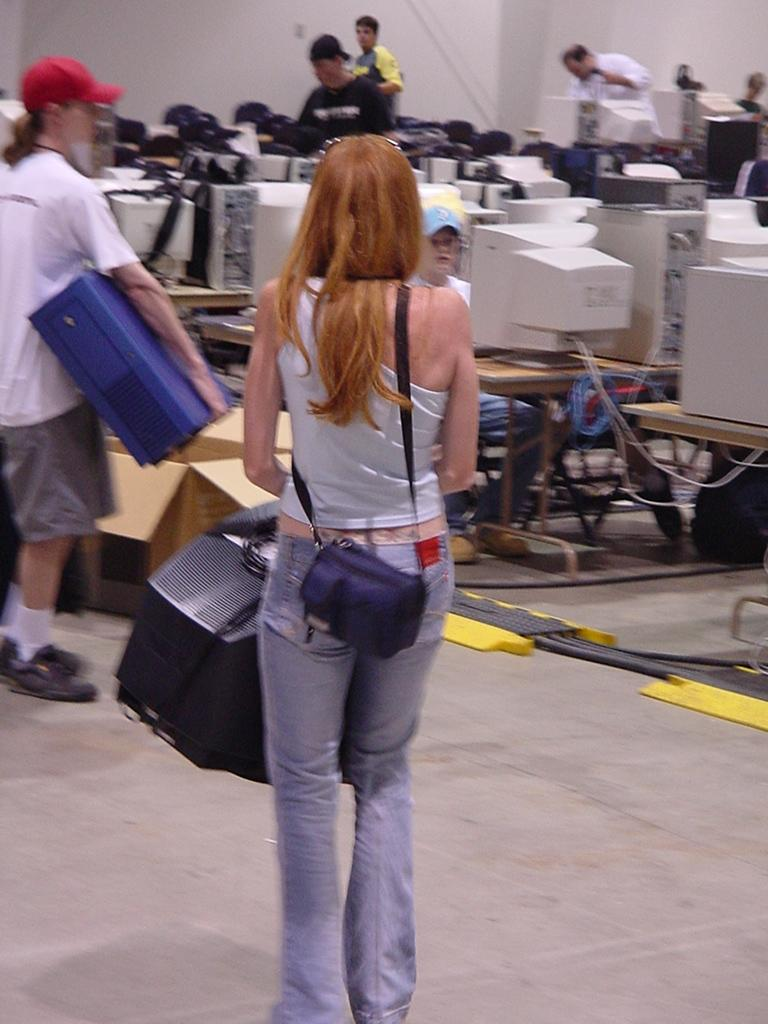What are the people in the image doing? There is a group of people on the floor in the image. What can be seen on the tables in the image? There are PCs on tables in the image. Can you describe any other objects in the image? There are some objects in the image, but their specific nature is not mentioned in the facts. What is visible in the background of the image? There is a wall in the background of the image. Where might this image have been taken? The image may have been taken in a hall, based on the presence of a group of people and PCs on tables. How many eyes can be seen in the image? There is no mention of eyes in the image, as it features a group of people on the floor and PCs on tables. What thoughts are the people in the image having? The thoughts of the people in the image cannot be determined from the image itself. 